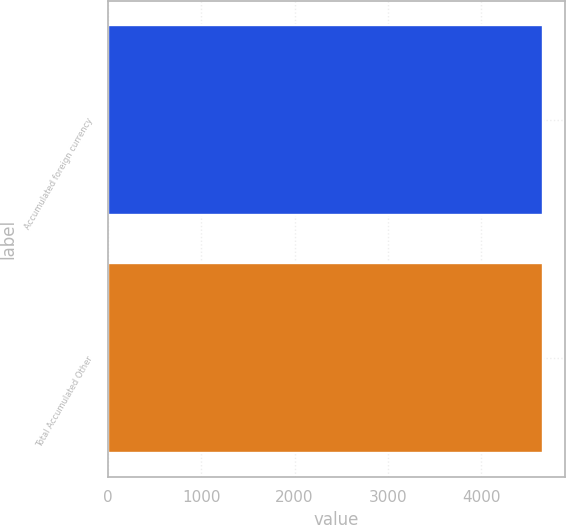Convert chart to OTSL. <chart><loc_0><loc_0><loc_500><loc_500><bar_chart><fcel>Accumulated foreign currency<fcel>Total Accumulated Other<nl><fcel>4662<fcel>4662.1<nl></chart> 